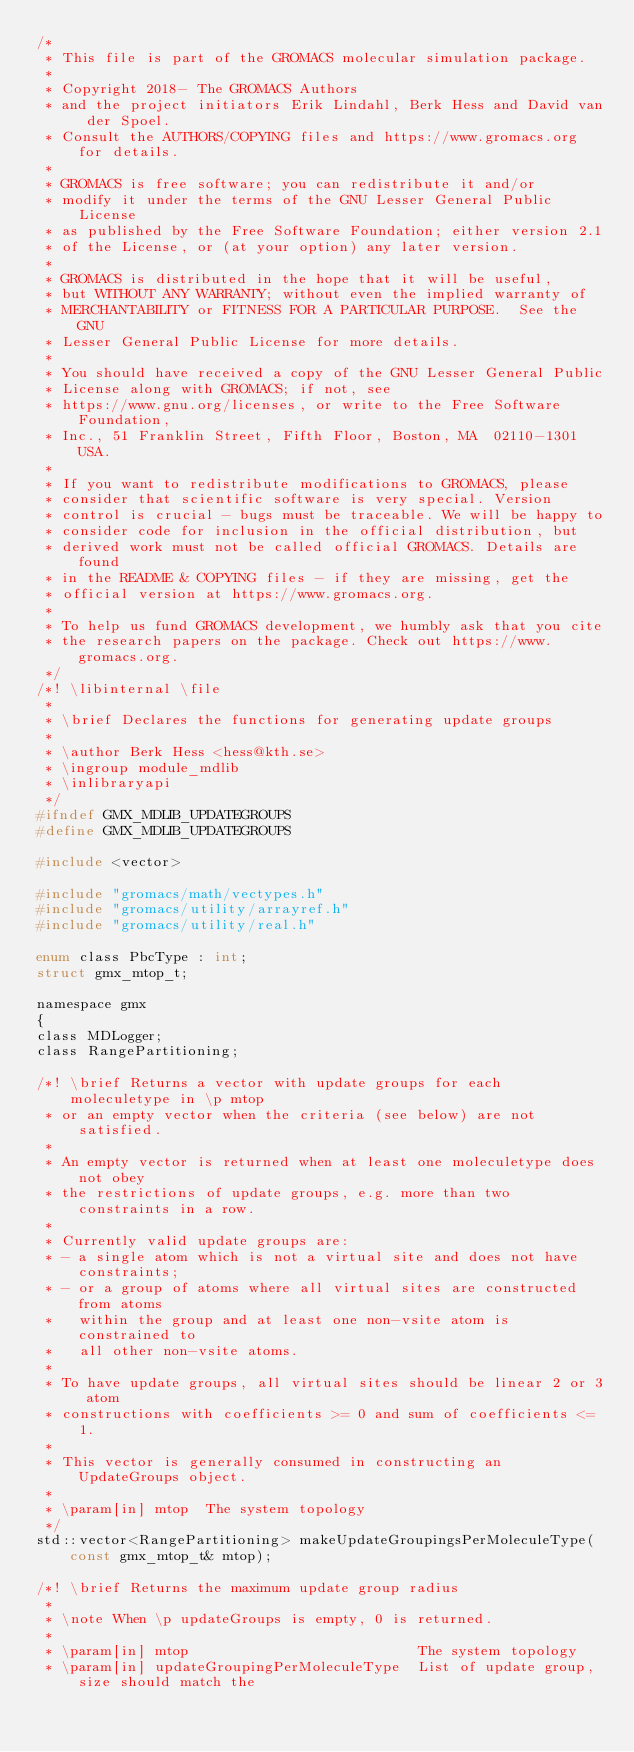<code> <loc_0><loc_0><loc_500><loc_500><_C_>/*
 * This file is part of the GROMACS molecular simulation package.
 *
 * Copyright 2018- The GROMACS Authors
 * and the project initiators Erik Lindahl, Berk Hess and David van der Spoel.
 * Consult the AUTHORS/COPYING files and https://www.gromacs.org for details.
 *
 * GROMACS is free software; you can redistribute it and/or
 * modify it under the terms of the GNU Lesser General Public License
 * as published by the Free Software Foundation; either version 2.1
 * of the License, or (at your option) any later version.
 *
 * GROMACS is distributed in the hope that it will be useful,
 * but WITHOUT ANY WARRANTY; without even the implied warranty of
 * MERCHANTABILITY or FITNESS FOR A PARTICULAR PURPOSE.  See the GNU
 * Lesser General Public License for more details.
 *
 * You should have received a copy of the GNU Lesser General Public
 * License along with GROMACS; if not, see
 * https://www.gnu.org/licenses, or write to the Free Software Foundation,
 * Inc., 51 Franklin Street, Fifth Floor, Boston, MA  02110-1301  USA.
 *
 * If you want to redistribute modifications to GROMACS, please
 * consider that scientific software is very special. Version
 * control is crucial - bugs must be traceable. We will be happy to
 * consider code for inclusion in the official distribution, but
 * derived work must not be called official GROMACS. Details are found
 * in the README & COPYING files - if they are missing, get the
 * official version at https://www.gromacs.org.
 *
 * To help us fund GROMACS development, we humbly ask that you cite
 * the research papers on the package. Check out https://www.gromacs.org.
 */
/*! \libinternal \file
 *
 * \brief Declares the functions for generating update groups
 *
 * \author Berk Hess <hess@kth.se>
 * \ingroup module_mdlib
 * \inlibraryapi
 */
#ifndef GMX_MDLIB_UPDATEGROUPS
#define GMX_MDLIB_UPDATEGROUPS

#include <vector>

#include "gromacs/math/vectypes.h"
#include "gromacs/utility/arrayref.h"
#include "gromacs/utility/real.h"

enum class PbcType : int;
struct gmx_mtop_t;

namespace gmx
{
class MDLogger;
class RangePartitioning;

/*! \brief Returns a vector with update groups for each moleculetype in \p mtop
 * or an empty vector when the criteria (see below) are not satisfied.
 *
 * An empty vector is returned when at least one moleculetype does not obey
 * the restrictions of update groups, e.g. more than two constraints in a row.
 *
 * Currently valid update groups are:
 * - a single atom which is not a virtual site and does not have constraints;
 * - or a group of atoms where all virtual sites are constructed from atoms
 *   within the group and at least one non-vsite atom is constrained to
 *   all other non-vsite atoms.
 *
 * To have update groups, all virtual sites should be linear 2 or 3 atom
 * constructions with coefficients >= 0 and sum of coefficients <= 1.
 *
 * This vector is generally consumed in constructing an UpdateGroups object.
 *
 * \param[in] mtop  The system topology
 */
std::vector<RangePartitioning> makeUpdateGroupingsPerMoleculeType(const gmx_mtop_t& mtop);

/*! \brief Returns the maximum update group radius
 *
 * \note When \p updateGroups is empty, 0 is returned.
 *
 * \param[in] mtop                           The system topology
 * \param[in] updateGroupingPerMoleculeType  List of update group, size should match the</code> 